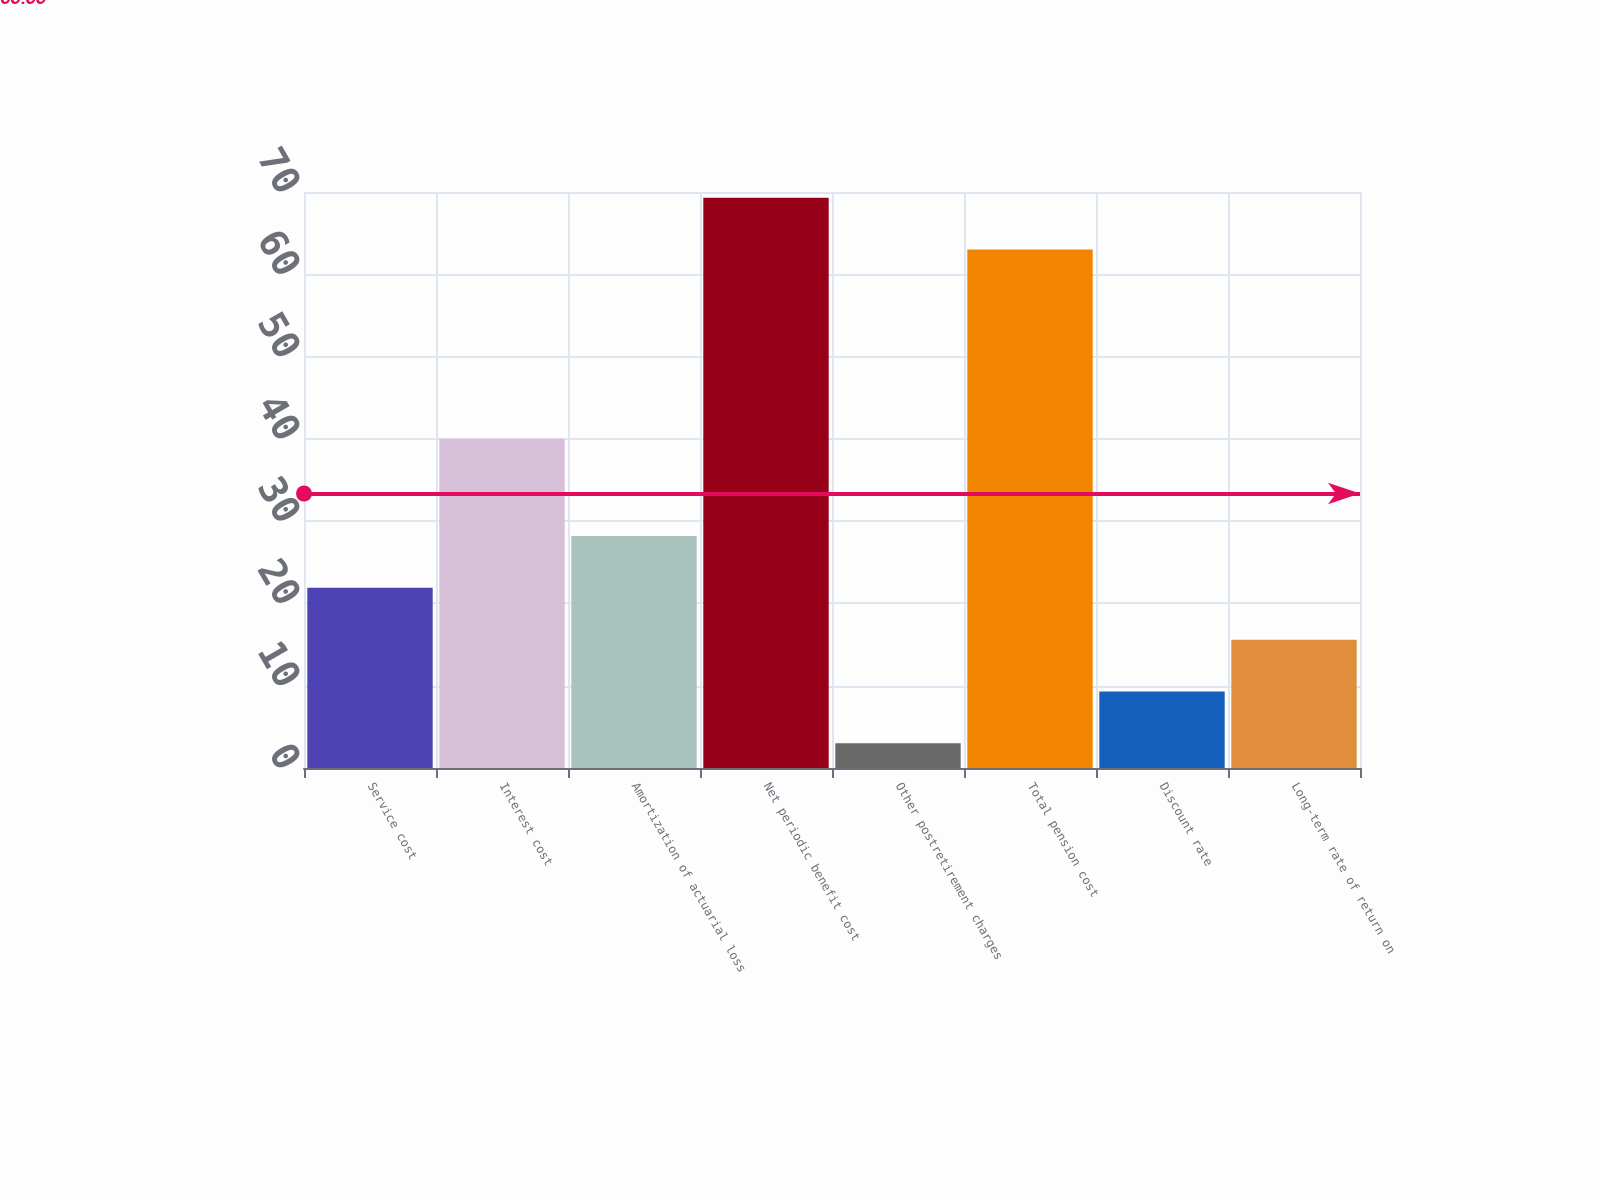Convert chart to OTSL. <chart><loc_0><loc_0><loc_500><loc_500><bar_chart><fcel>Service cost<fcel>Interest cost<fcel>Amortization of actuarial loss<fcel>Net periodic benefit cost<fcel>Other postretirement charges<fcel>Total pension cost<fcel>Discount rate<fcel>Long-term rate of return on<nl><fcel>21.9<fcel>40<fcel>28.2<fcel>69.3<fcel>3<fcel>63<fcel>9.3<fcel>15.6<nl></chart> 